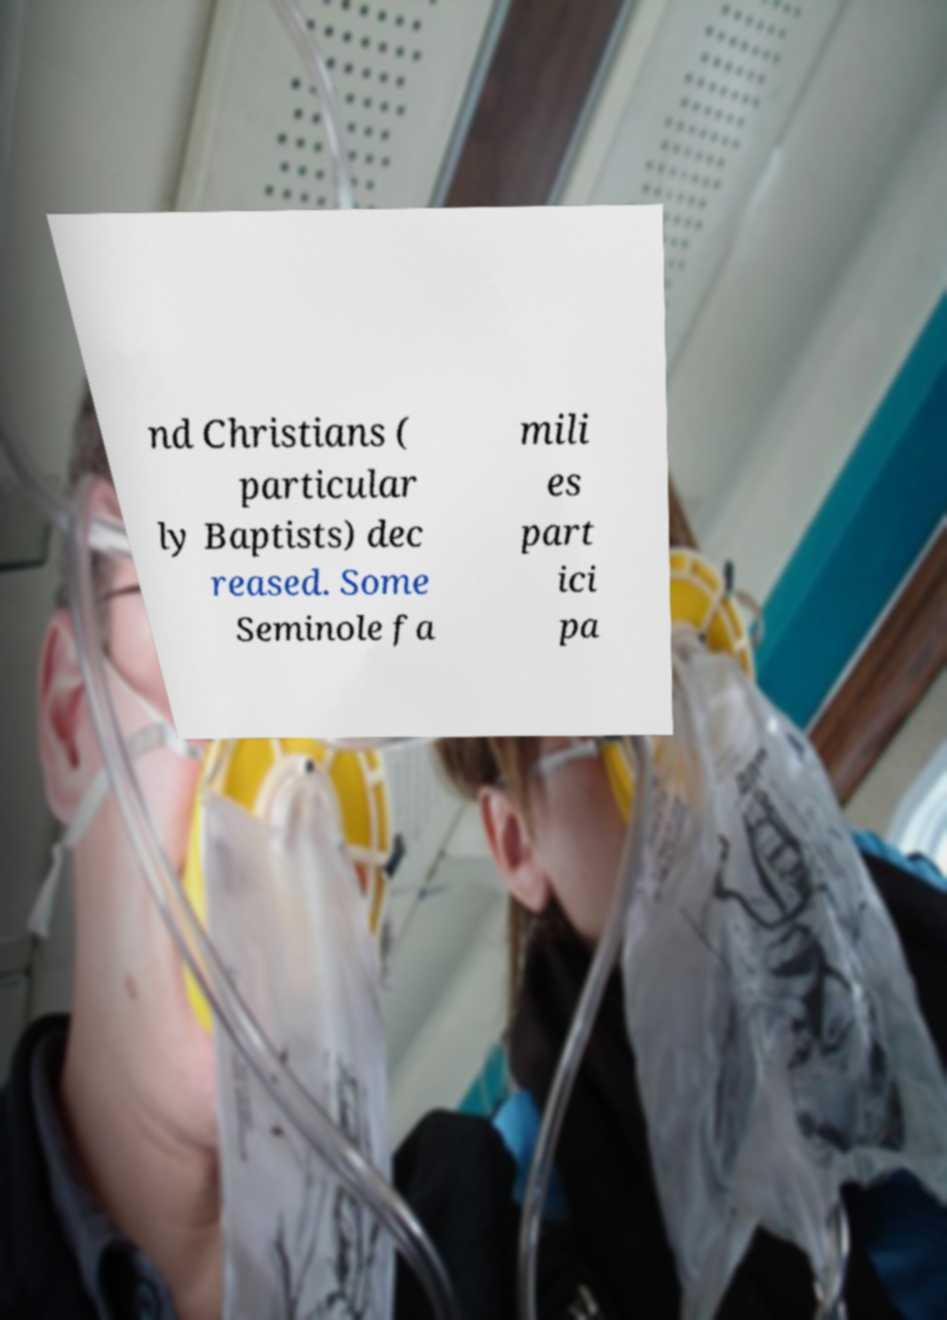For documentation purposes, I need the text within this image transcribed. Could you provide that? nd Christians ( particular ly Baptists) dec reased. Some Seminole fa mili es part ici pa 